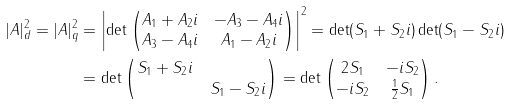Convert formula to latex. <formula><loc_0><loc_0><loc_500><loc_500>| A | _ { d } ^ { 2 } = | A | _ { q } ^ { 2 } & = \left | \det \begin{pmatrix} A _ { 1 } + A _ { 2 } i & - A _ { 3 } - A _ { 4 } i \\ A _ { 3 } - A _ { 4 } i & A _ { 1 } - A _ { 2 } i \end{pmatrix} \right | ^ { 2 } = \det ( S _ { 1 } + S _ { 2 } i ) \det ( S _ { 1 } - S _ { 2 } i ) \\ & = \det \begin{pmatrix} S _ { 1 } + S _ { 2 } i \\ & S _ { 1 } - S _ { 2 } i \end{pmatrix} = \det \begin{pmatrix} 2 S _ { 1 } & - i S _ { 2 } \\ - i S _ { 2 } & \frac { 1 } { 2 } S _ { 1 } \end{pmatrix} .</formula> 